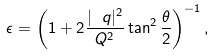Convert formula to latex. <formula><loc_0><loc_0><loc_500><loc_500>\epsilon = \left ( 1 + 2 \frac { | \ q | ^ { 2 } } { Q ^ { 2 } } \tan ^ { 2 } \frac { \theta } { 2 } \right ) ^ { - 1 } ,</formula> 